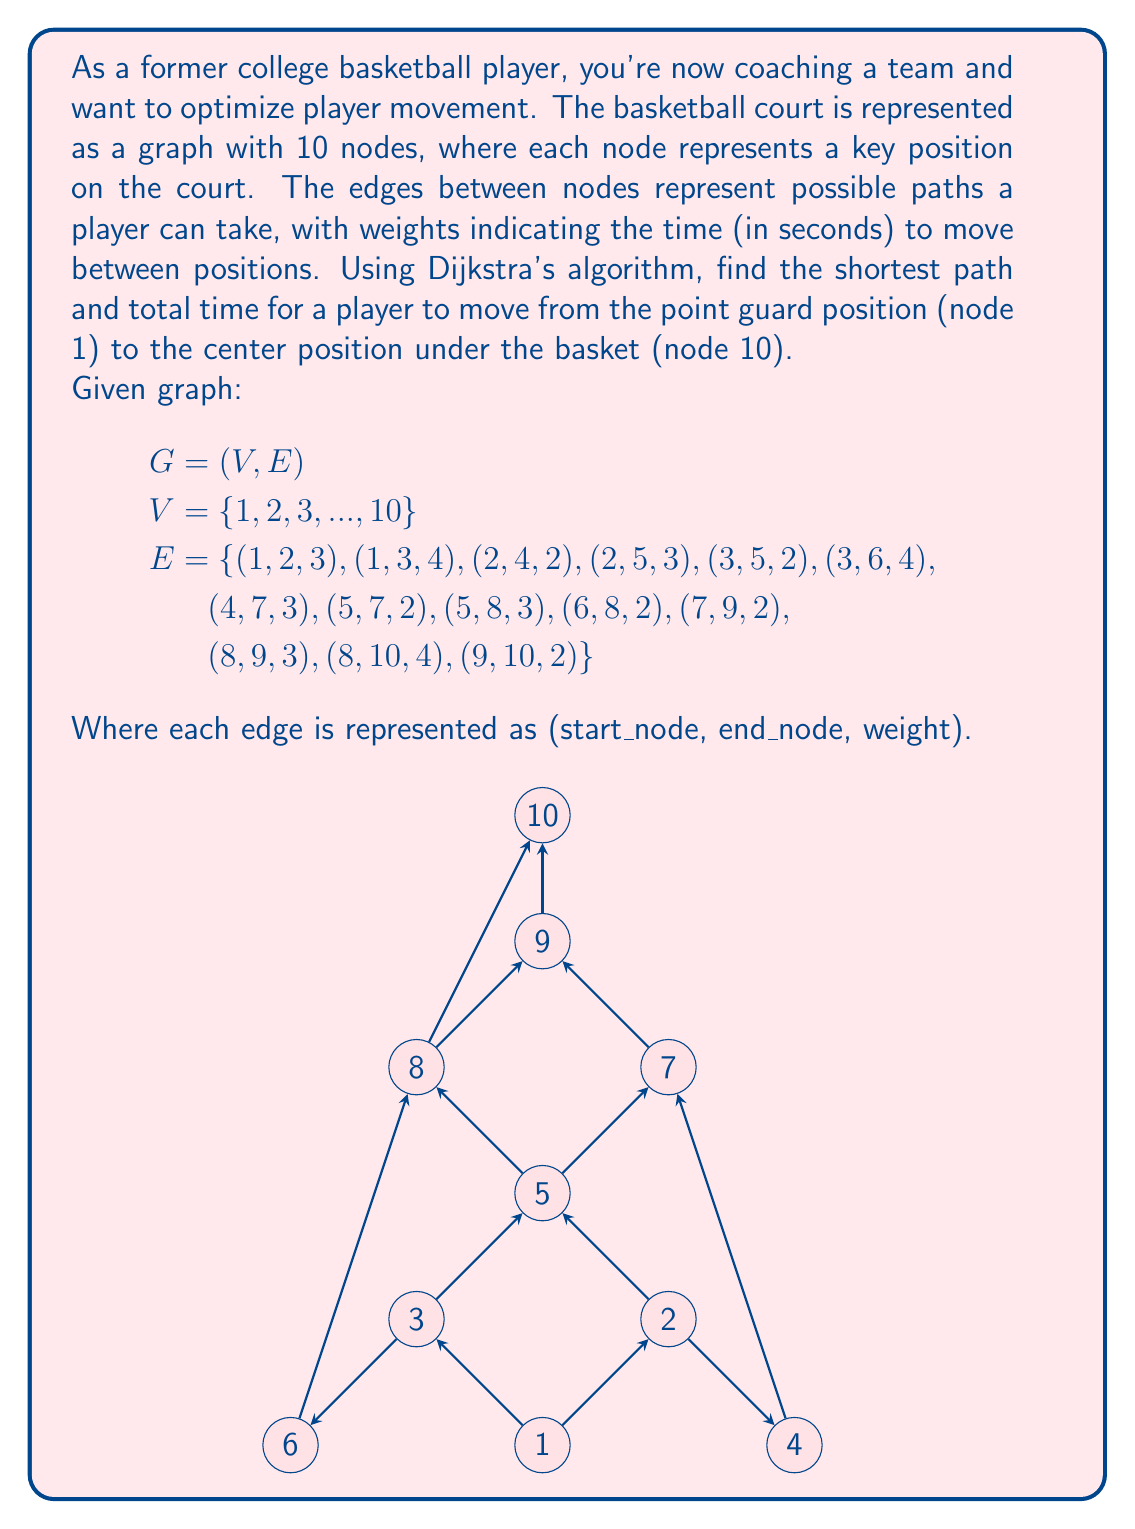Show me your answer to this math problem. To solve this problem, we'll use Dijkstra's algorithm to find the shortest path from node 1 to node 10. Here's a step-by-step explanation:

1) Initialize distances:
   Set distance to node 1 as 0 and all other nodes as infinity.
   $d = [0, \infty, \infty, \infty, \infty, \infty, \infty, \infty, \infty, \infty]$

2) Create a priority queue Q with all nodes, prioritized by their distance.

3) While Q is not empty:
   a) Extract the node u with the minimum distance from Q.
   b) For each neighbor v of u:
      If $d[v] > d[u] + w(u,v)$, then $d[v] = d[u] + w(u,v)$
      Update v's position in Q.

4) Iteration process:
   - Start with node 1: Update d[2] = 3, d[3] = 4
   - Node 2: Update d[4] = 5, d[5] = 6
   - Node 3: Update d[5] = 6, d[6] = 8
   - Node 4: Update d[7] = 8
   - Node 5: Update d[7] = 8, d[8] = 9
   - Node 6: No updates
   - Node 7: Update d[9] = 10
   - Node 8: Update d[9] = 12, d[10] = 13
   - Node 9: Update d[10] = 12

5) The shortest path is found: 1 -> 2 -> 4 -> 7 -> 9 -> 10

6) Total time: 12 seconds

To reconstruct the path, we keep track of the previous node for each updated node during the algorithm execution.
Answer: The shortest path from node 1 (point guard position) to node 10 (center position) is:
1 -> 2 -> 4 -> 7 -> 9 -> 10

Total time: 12 seconds 